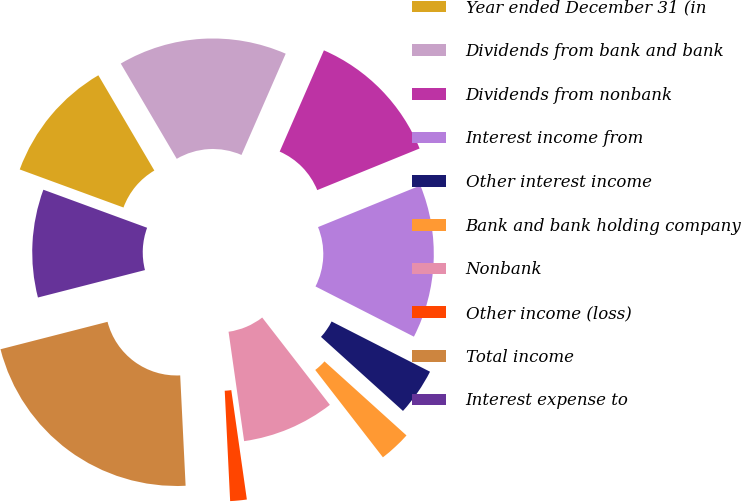Convert chart. <chart><loc_0><loc_0><loc_500><loc_500><pie_chart><fcel>Year ended December 31 (in<fcel>Dividends from bank and bank<fcel>Dividends from nonbank<fcel>Interest income from<fcel>Other interest income<fcel>Bank and bank holding company<fcel>Nonbank<fcel>Other income (loss)<fcel>Total income<fcel>Interest expense to<nl><fcel>10.95%<fcel>15.01%<fcel>12.3%<fcel>13.66%<fcel>4.18%<fcel>2.82%<fcel>8.24%<fcel>1.47%<fcel>21.79%<fcel>9.59%<nl></chart> 